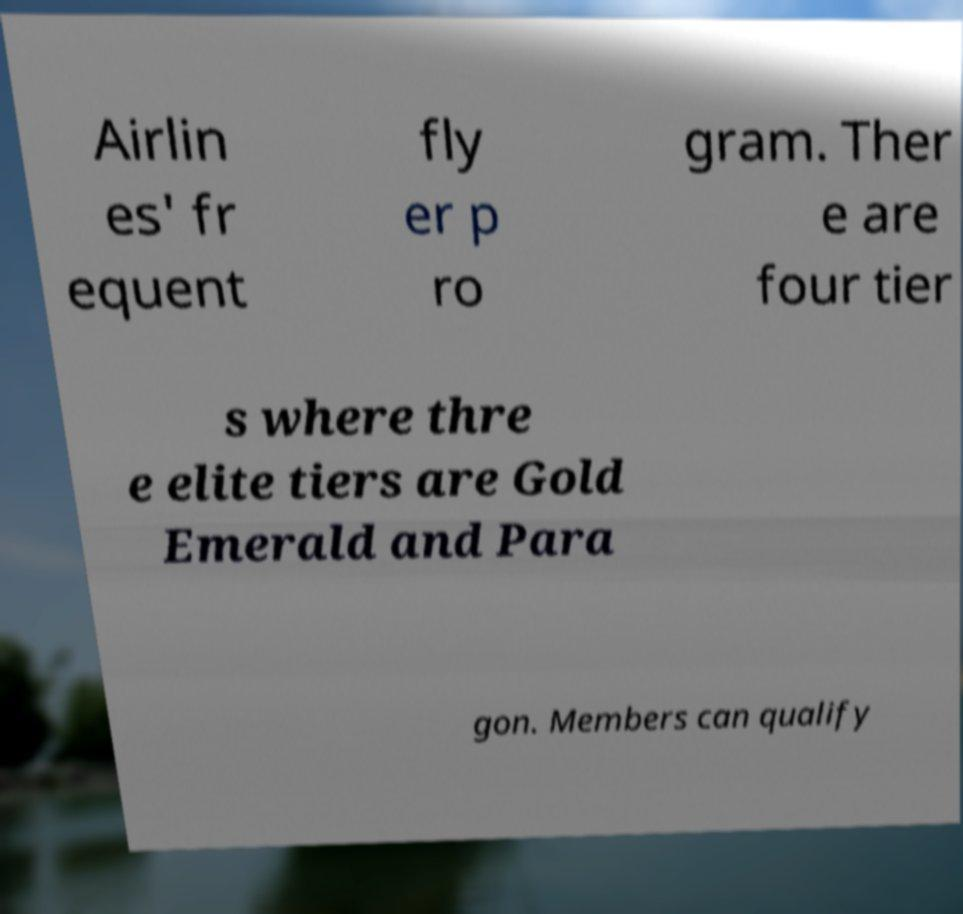What messages or text are displayed in this image? I need them in a readable, typed format. Airlin es' fr equent fly er p ro gram. Ther e are four tier s where thre e elite tiers are Gold Emerald and Para gon. Members can qualify 